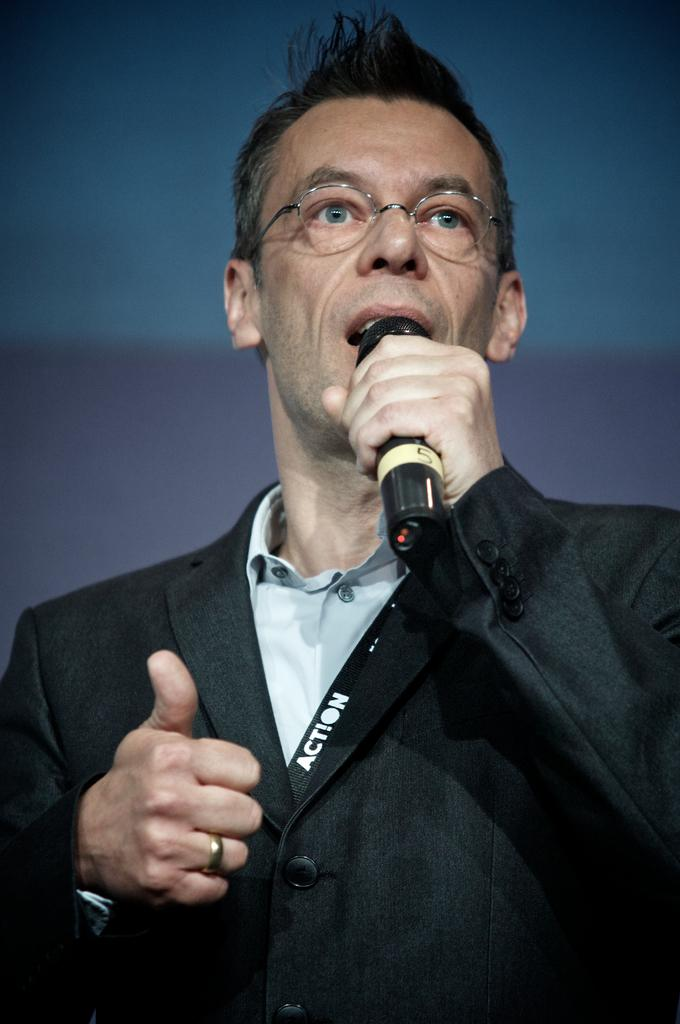Who is in the image? There is a person in the image. What is the person wearing? The person is wearing a suit. What object is the person holding? The person is holding a microphone. What is the person doing with the microphone? The person is talking. What type of pot is the person using to care for the plants in the image? There is no pot or plants present in the image; the person is holding a microphone and talking. 